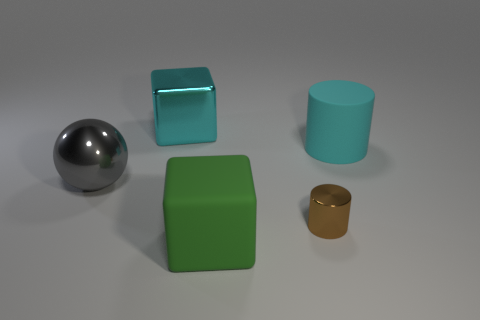Subtract all green cubes. How many cubes are left? 1 Subtract 1 cylinders. How many cylinders are left? 1 Subtract all red cubes. How many brown cylinders are left? 1 Subtract all balls. How many objects are left? 4 Subtract all blue blocks. Subtract all green cylinders. How many blocks are left? 2 Subtract all tiny purple shiny spheres. Subtract all cyan cylinders. How many objects are left? 4 Add 2 tiny things. How many tiny things are left? 3 Add 3 red metal things. How many red metal things exist? 3 Add 4 big matte cylinders. How many objects exist? 9 Subtract 0 yellow spheres. How many objects are left? 5 